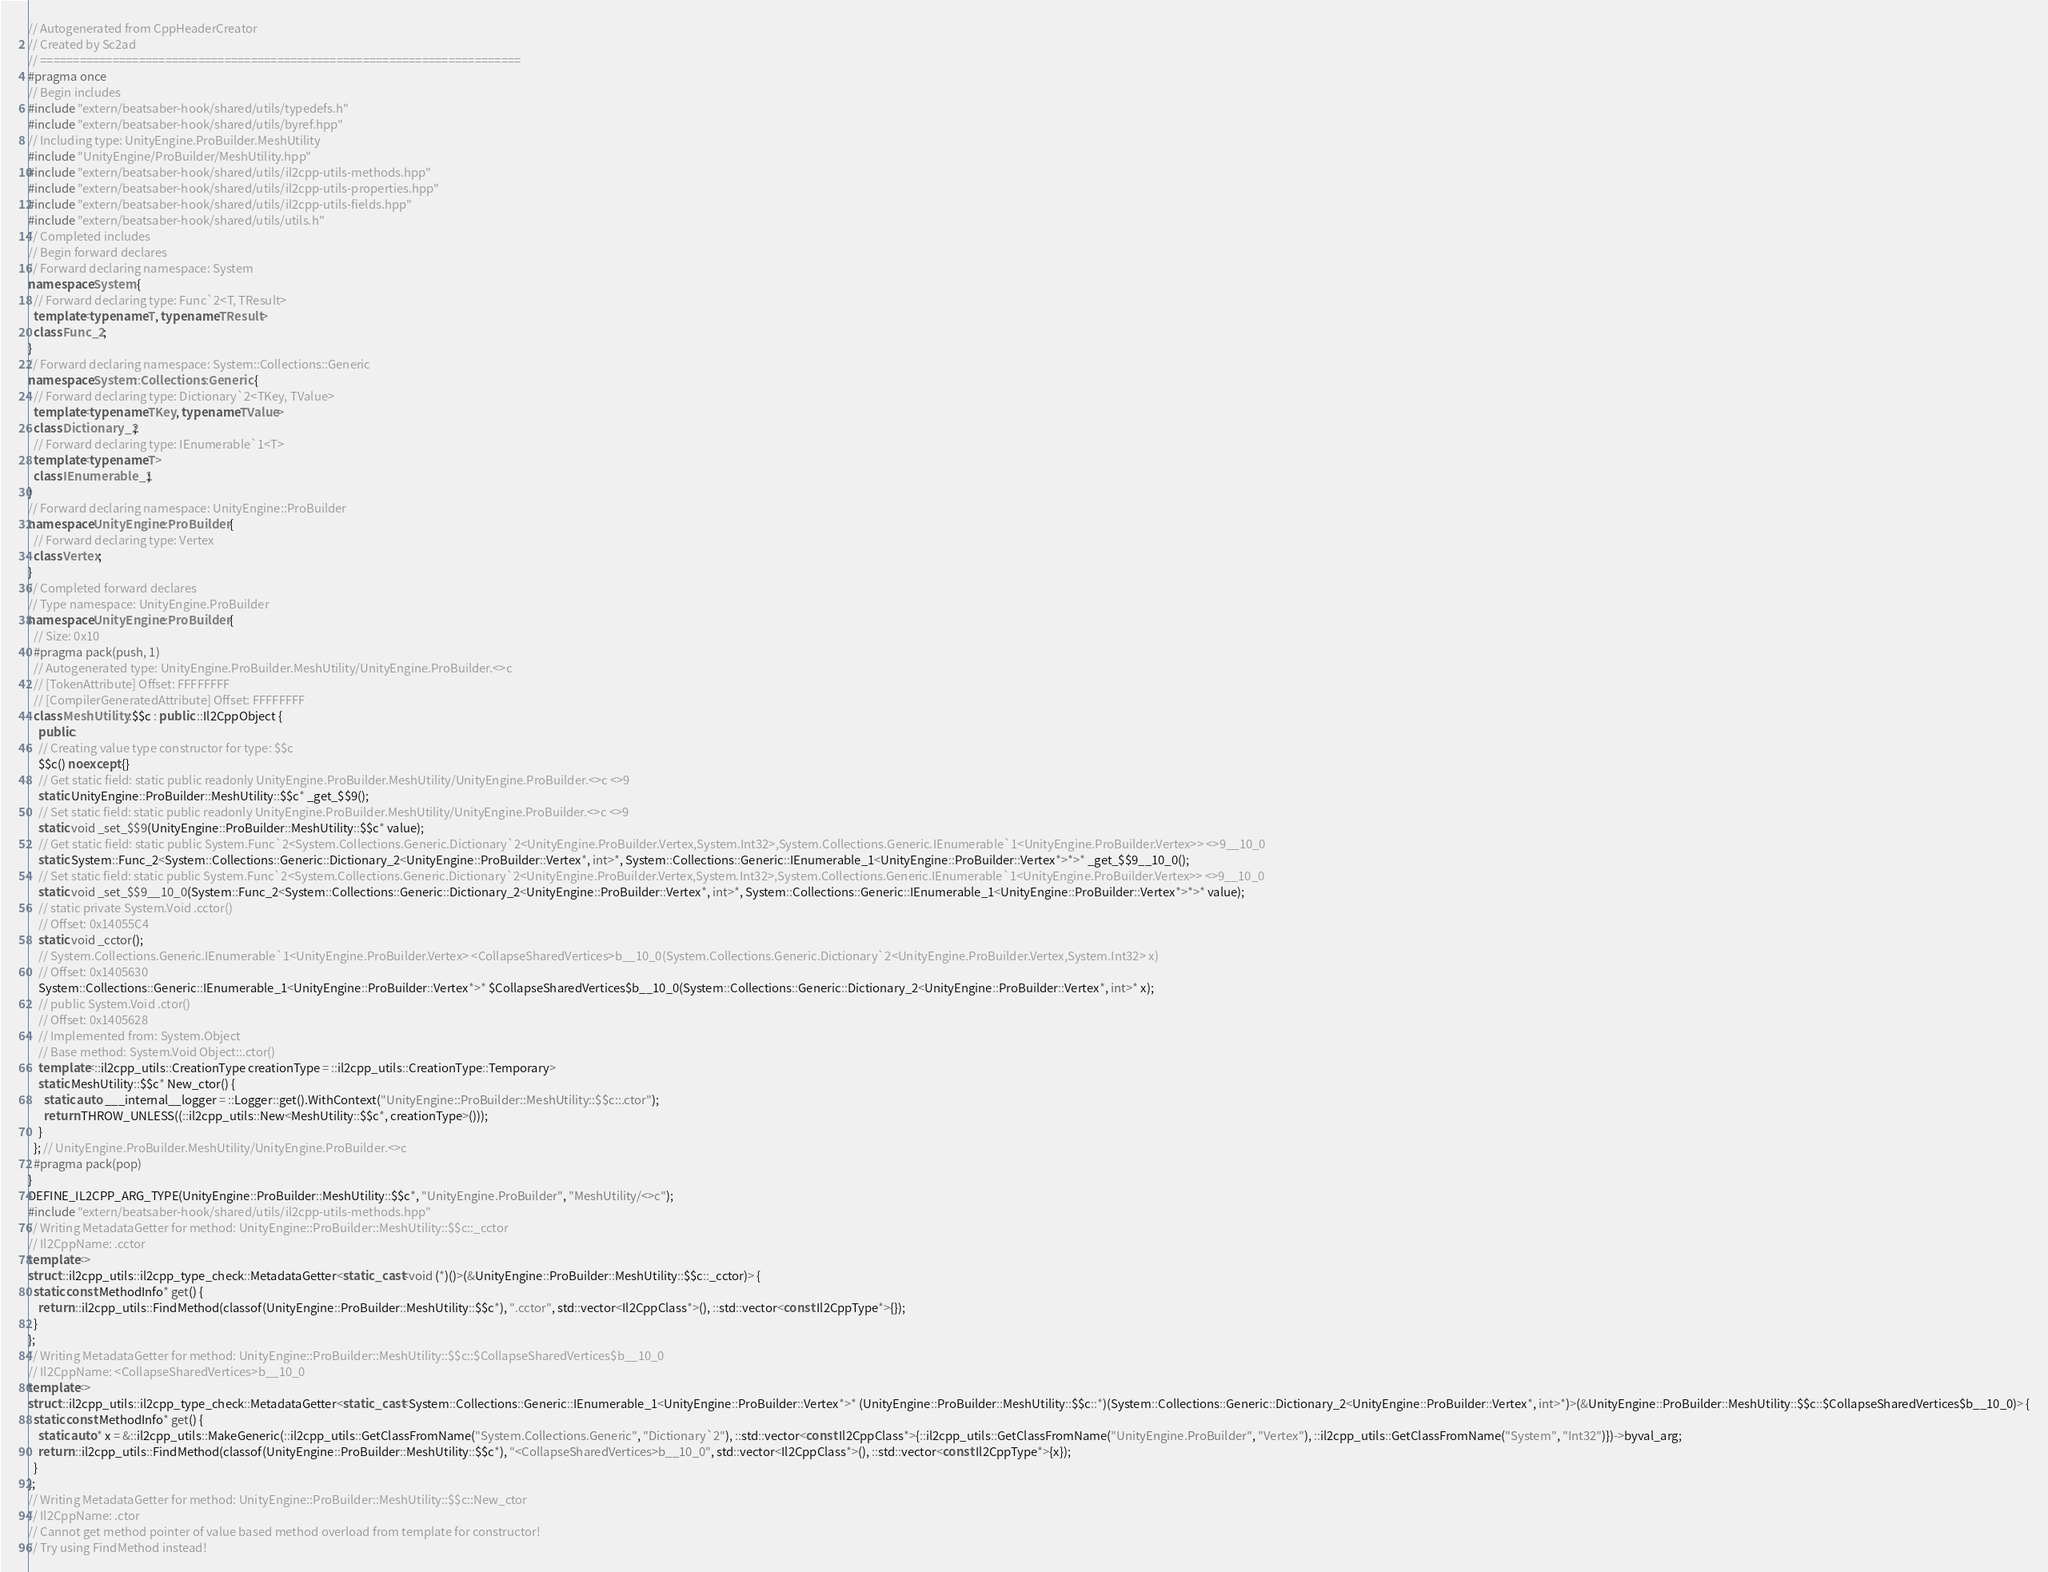Convert code to text. <code><loc_0><loc_0><loc_500><loc_500><_C++_>// Autogenerated from CppHeaderCreator
// Created by Sc2ad
// =========================================================================
#pragma once
// Begin includes
#include "extern/beatsaber-hook/shared/utils/typedefs.h"
#include "extern/beatsaber-hook/shared/utils/byref.hpp"
// Including type: UnityEngine.ProBuilder.MeshUtility
#include "UnityEngine/ProBuilder/MeshUtility.hpp"
#include "extern/beatsaber-hook/shared/utils/il2cpp-utils-methods.hpp"
#include "extern/beatsaber-hook/shared/utils/il2cpp-utils-properties.hpp"
#include "extern/beatsaber-hook/shared/utils/il2cpp-utils-fields.hpp"
#include "extern/beatsaber-hook/shared/utils/utils.h"
// Completed includes
// Begin forward declares
// Forward declaring namespace: System
namespace System {
  // Forward declaring type: Func`2<T, TResult>
  template<typename T, typename TResult>
  class Func_2;
}
// Forward declaring namespace: System::Collections::Generic
namespace System::Collections::Generic {
  // Forward declaring type: Dictionary`2<TKey, TValue>
  template<typename TKey, typename TValue>
  class Dictionary_2;
  // Forward declaring type: IEnumerable`1<T>
  template<typename T>
  class IEnumerable_1;
}
// Forward declaring namespace: UnityEngine::ProBuilder
namespace UnityEngine::ProBuilder {
  // Forward declaring type: Vertex
  class Vertex;
}
// Completed forward declares
// Type namespace: UnityEngine.ProBuilder
namespace UnityEngine::ProBuilder {
  // Size: 0x10
  #pragma pack(push, 1)
  // Autogenerated type: UnityEngine.ProBuilder.MeshUtility/UnityEngine.ProBuilder.<>c
  // [TokenAttribute] Offset: FFFFFFFF
  // [CompilerGeneratedAttribute] Offset: FFFFFFFF
  class MeshUtility::$$c : public ::Il2CppObject {
    public:
    // Creating value type constructor for type: $$c
    $$c() noexcept {}
    // Get static field: static public readonly UnityEngine.ProBuilder.MeshUtility/UnityEngine.ProBuilder.<>c <>9
    static UnityEngine::ProBuilder::MeshUtility::$$c* _get_$$9();
    // Set static field: static public readonly UnityEngine.ProBuilder.MeshUtility/UnityEngine.ProBuilder.<>c <>9
    static void _set_$$9(UnityEngine::ProBuilder::MeshUtility::$$c* value);
    // Get static field: static public System.Func`2<System.Collections.Generic.Dictionary`2<UnityEngine.ProBuilder.Vertex,System.Int32>,System.Collections.Generic.IEnumerable`1<UnityEngine.ProBuilder.Vertex>> <>9__10_0
    static System::Func_2<System::Collections::Generic::Dictionary_2<UnityEngine::ProBuilder::Vertex*, int>*, System::Collections::Generic::IEnumerable_1<UnityEngine::ProBuilder::Vertex*>*>* _get_$$9__10_0();
    // Set static field: static public System.Func`2<System.Collections.Generic.Dictionary`2<UnityEngine.ProBuilder.Vertex,System.Int32>,System.Collections.Generic.IEnumerable`1<UnityEngine.ProBuilder.Vertex>> <>9__10_0
    static void _set_$$9__10_0(System::Func_2<System::Collections::Generic::Dictionary_2<UnityEngine::ProBuilder::Vertex*, int>*, System::Collections::Generic::IEnumerable_1<UnityEngine::ProBuilder::Vertex*>*>* value);
    // static private System.Void .cctor()
    // Offset: 0x14055C4
    static void _cctor();
    // System.Collections.Generic.IEnumerable`1<UnityEngine.ProBuilder.Vertex> <CollapseSharedVertices>b__10_0(System.Collections.Generic.Dictionary`2<UnityEngine.ProBuilder.Vertex,System.Int32> x)
    // Offset: 0x1405630
    System::Collections::Generic::IEnumerable_1<UnityEngine::ProBuilder::Vertex*>* $CollapseSharedVertices$b__10_0(System::Collections::Generic::Dictionary_2<UnityEngine::ProBuilder::Vertex*, int>* x);
    // public System.Void .ctor()
    // Offset: 0x1405628
    // Implemented from: System.Object
    // Base method: System.Void Object::.ctor()
    template<::il2cpp_utils::CreationType creationType = ::il2cpp_utils::CreationType::Temporary>
    static MeshUtility::$$c* New_ctor() {
      static auto ___internal__logger = ::Logger::get().WithContext("UnityEngine::ProBuilder::MeshUtility::$$c::.ctor");
      return THROW_UNLESS((::il2cpp_utils::New<MeshUtility::$$c*, creationType>()));
    }
  }; // UnityEngine.ProBuilder.MeshUtility/UnityEngine.ProBuilder.<>c
  #pragma pack(pop)
}
DEFINE_IL2CPP_ARG_TYPE(UnityEngine::ProBuilder::MeshUtility::$$c*, "UnityEngine.ProBuilder", "MeshUtility/<>c");
#include "extern/beatsaber-hook/shared/utils/il2cpp-utils-methods.hpp"
// Writing MetadataGetter for method: UnityEngine::ProBuilder::MeshUtility::$$c::_cctor
// Il2CppName: .cctor
template<>
struct ::il2cpp_utils::il2cpp_type_check::MetadataGetter<static_cast<void (*)()>(&UnityEngine::ProBuilder::MeshUtility::$$c::_cctor)> {
  static const MethodInfo* get() {
    return ::il2cpp_utils::FindMethod(classof(UnityEngine::ProBuilder::MeshUtility::$$c*), ".cctor", std::vector<Il2CppClass*>(), ::std::vector<const Il2CppType*>{});
  }
};
// Writing MetadataGetter for method: UnityEngine::ProBuilder::MeshUtility::$$c::$CollapseSharedVertices$b__10_0
// Il2CppName: <CollapseSharedVertices>b__10_0
template<>
struct ::il2cpp_utils::il2cpp_type_check::MetadataGetter<static_cast<System::Collections::Generic::IEnumerable_1<UnityEngine::ProBuilder::Vertex*>* (UnityEngine::ProBuilder::MeshUtility::$$c::*)(System::Collections::Generic::Dictionary_2<UnityEngine::ProBuilder::Vertex*, int>*)>(&UnityEngine::ProBuilder::MeshUtility::$$c::$CollapseSharedVertices$b__10_0)> {
  static const MethodInfo* get() {
    static auto* x = &::il2cpp_utils::MakeGeneric(::il2cpp_utils::GetClassFromName("System.Collections.Generic", "Dictionary`2"), ::std::vector<const Il2CppClass*>{::il2cpp_utils::GetClassFromName("UnityEngine.ProBuilder", "Vertex"), ::il2cpp_utils::GetClassFromName("System", "Int32")})->byval_arg;
    return ::il2cpp_utils::FindMethod(classof(UnityEngine::ProBuilder::MeshUtility::$$c*), "<CollapseSharedVertices>b__10_0", std::vector<Il2CppClass*>(), ::std::vector<const Il2CppType*>{x});
  }
};
// Writing MetadataGetter for method: UnityEngine::ProBuilder::MeshUtility::$$c::New_ctor
// Il2CppName: .ctor
// Cannot get method pointer of value based method overload from template for constructor!
// Try using FindMethod instead!
</code> 